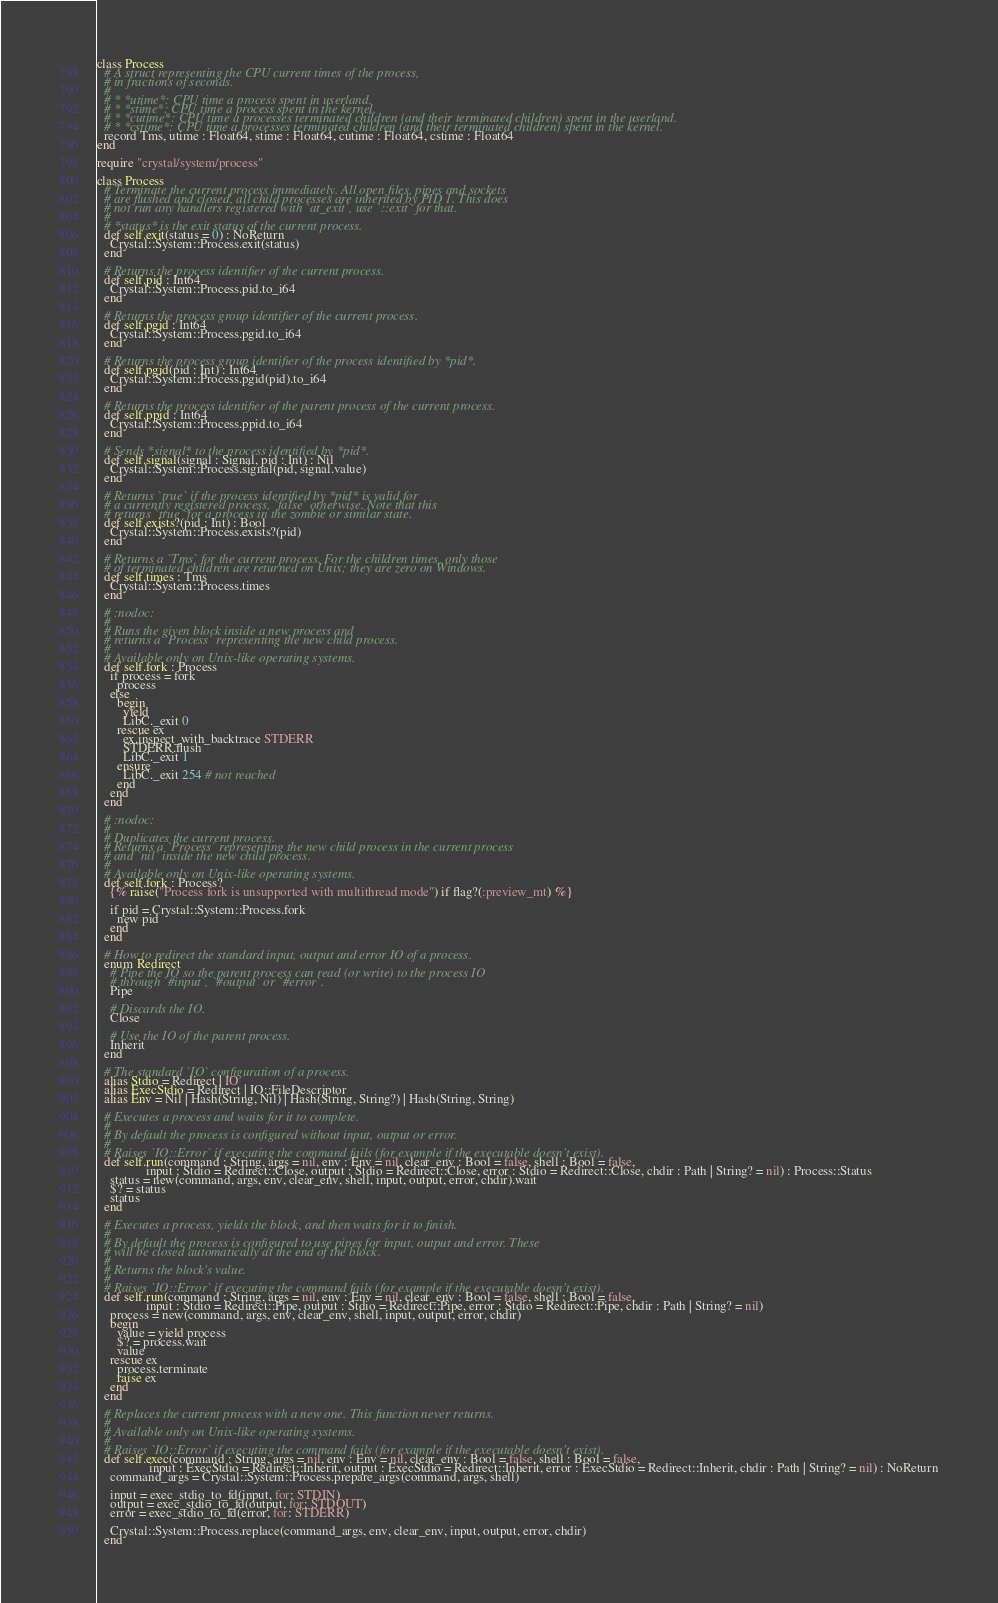Convert code to text. <code><loc_0><loc_0><loc_500><loc_500><_Crystal_>class Process
  # A struct representing the CPU current times of the process,
  # in fractions of seconds.
  #
  # * *utime*: CPU time a process spent in userland.
  # * *stime*: CPU time a process spent in the kernel.
  # * *cutime*: CPU time a processes terminated children (and their terminated children) spent in the userland.
  # * *cstime*: CPU time a processes terminated children (and their terminated children) spent in the kernel.
  record Tms, utime : Float64, stime : Float64, cutime : Float64, cstime : Float64
end

require "crystal/system/process"

class Process
  # Terminate the current process immediately. All open files, pipes and sockets
  # are flushed and closed, all child processes are inherited by PID 1. This does
  # not run any handlers registered with `at_exit`, use `::exit` for that.
  #
  # *status* is the exit status of the current process.
  def self.exit(status = 0) : NoReturn
    Crystal::System::Process.exit(status)
  end

  # Returns the process identifier of the current process.
  def self.pid : Int64
    Crystal::System::Process.pid.to_i64
  end

  # Returns the process group identifier of the current process.
  def self.pgid : Int64
    Crystal::System::Process.pgid.to_i64
  end

  # Returns the process group identifier of the process identified by *pid*.
  def self.pgid(pid : Int) : Int64
    Crystal::System::Process.pgid(pid).to_i64
  end

  # Returns the process identifier of the parent process of the current process.
  def self.ppid : Int64
    Crystal::System::Process.ppid.to_i64
  end

  # Sends *signal* to the process identified by *pid*.
  def self.signal(signal : Signal, pid : Int) : Nil
    Crystal::System::Process.signal(pid, signal.value)
  end

  # Returns `true` if the process identified by *pid* is valid for
  # a currently registered process, `false` otherwise. Note that this
  # returns `true` for a process in the zombie or similar state.
  def self.exists?(pid : Int) : Bool
    Crystal::System::Process.exists?(pid)
  end

  # Returns a `Tms` for the current process. For the children times, only those
  # of terminated children are returned on Unix; they are zero on Windows.
  def self.times : Tms
    Crystal::System::Process.times
  end

  # :nodoc:
  #
  # Runs the given block inside a new process and
  # returns a `Process` representing the new child process.
  #
  # Available only on Unix-like operating systems.
  def self.fork : Process
    if process = fork
      process
    else
      begin
        yield
        LibC._exit 0
      rescue ex
        ex.inspect_with_backtrace STDERR
        STDERR.flush
        LibC._exit 1
      ensure
        LibC._exit 254 # not reached
      end
    end
  end

  # :nodoc:
  #
  # Duplicates the current process.
  # Returns a `Process` representing the new child process in the current process
  # and `nil` inside the new child process.
  #
  # Available only on Unix-like operating systems.
  def self.fork : Process?
    {% raise("Process fork is unsupported with multithread mode") if flag?(:preview_mt) %}

    if pid = Crystal::System::Process.fork
      new pid
    end
  end

  # How to redirect the standard input, output and error IO of a process.
  enum Redirect
    # Pipe the IO so the parent process can read (or write) to the process IO
    # through `#input`, `#output` or `#error`.
    Pipe

    # Discards the IO.
    Close

    # Use the IO of the parent process.
    Inherit
  end

  # The standard `IO` configuration of a process.
  alias Stdio = Redirect | IO
  alias ExecStdio = Redirect | IO::FileDescriptor
  alias Env = Nil | Hash(String, Nil) | Hash(String, String?) | Hash(String, String)

  # Executes a process and waits for it to complete.
  #
  # By default the process is configured without input, output or error.
  #
  # Raises `IO::Error` if executing the command fails (for example if the executable doesn't exist).
  def self.run(command : String, args = nil, env : Env = nil, clear_env : Bool = false, shell : Bool = false,
               input : Stdio = Redirect::Close, output : Stdio = Redirect::Close, error : Stdio = Redirect::Close, chdir : Path | String? = nil) : Process::Status
    status = new(command, args, env, clear_env, shell, input, output, error, chdir).wait
    $? = status
    status
  end

  # Executes a process, yields the block, and then waits for it to finish.
  #
  # By default the process is configured to use pipes for input, output and error. These
  # will be closed automatically at the end of the block.
  #
  # Returns the block's value.
  #
  # Raises `IO::Error` if executing the command fails (for example if the executable doesn't exist).
  def self.run(command : String, args = nil, env : Env = nil, clear_env : Bool = false, shell : Bool = false,
               input : Stdio = Redirect::Pipe, output : Stdio = Redirect::Pipe, error : Stdio = Redirect::Pipe, chdir : Path | String? = nil)
    process = new(command, args, env, clear_env, shell, input, output, error, chdir)
    begin
      value = yield process
      $? = process.wait
      value
    rescue ex
      process.terminate
      raise ex
    end
  end

  # Replaces the current process with a new one. This function never returns.
  #
  # Available only on Unix-like operating systems.
  #
  # Raises `IO::Error` if executing the command fails (for example if the executable doesn't exist).
  def self.exec(command : String, args = nil, env : Env = nil, clear_env : Bool = false, shell : Bool = false,
                input : ExecStdio = Redirect::Inherit, output : ExecStdio = Redirect::Inherit, error : ExecStdio = Redirect::Inherit, chdir : Path | String? = nil) : NoReturn
    command_args = Crystal::System::Process.prepare_args(command, args, shell)

    input = exec_stdio_to_fd(input, for: STDIN)
    output = exec_stdio_to_fd(output, for: STDOUT)
    error = exec_stdio_to_fd(error, for: STDERR)

    Crystal::System::Process.replace(command_args, env, clear_env, input, output, error, chdir)
  end
</code> 